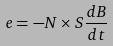Convert formula to latex. <formula><loc_0><loc_0><loc_500><loc_500>e = - N \times S \frac { d B } { d t }</formula> 